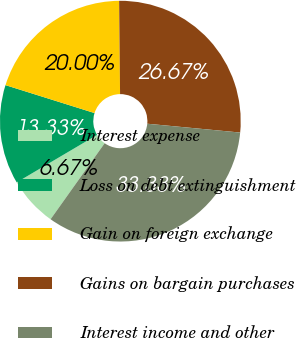Convert chart. <chart><loc_0><loc_0><loc_500><loc_500><pie_chart><fcel>Interest expense<fcel>Loss on debt extinguishment<fcel>Gain on foreign exchange<fcel>Gains on bargain purchases<fcel>Interest income and other<nl><fcel>6.67%<fcel>13.33%<fcel>20.0%<fcel>26.67%<fcel>33.33%<nl></chart> 